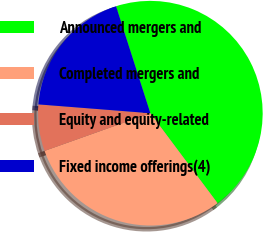Convert chart. <chart><loc_0><loc_0><loc_500><loc_500><pie_chart><fcel>Announced mergers and<fcel>Completed mergers and<fcel>Equity and equity-related<fcel>Fixed income offerings(4)<nl><fcel>44.73%<fcel>29.77%<fcel>6.69%<fcel>18.81%<nl></chart> 